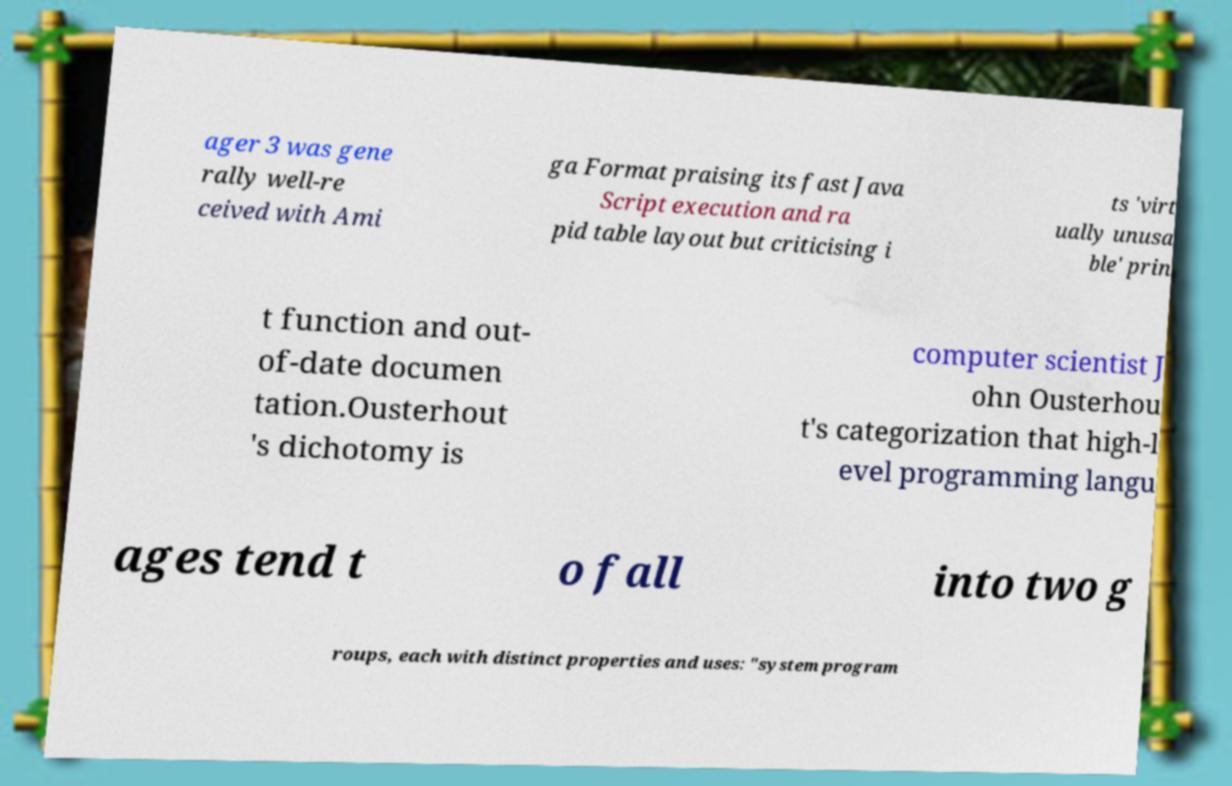Could you extract and type out the text from this image? ager 3 was gene rally well-re ceived with Ami ga Format praising its fast Java Script execution and ra pid table layout but criticising i ts 'virt ually unusa ble' prin t function and out- of-date documen tation.Ousterhout 's dichotomy is computer scientist J ohn Ousterhou t's categorization that high-l evel programming langu ages tend t o fall into two g roups, each with distinct properties and uses: "system program 